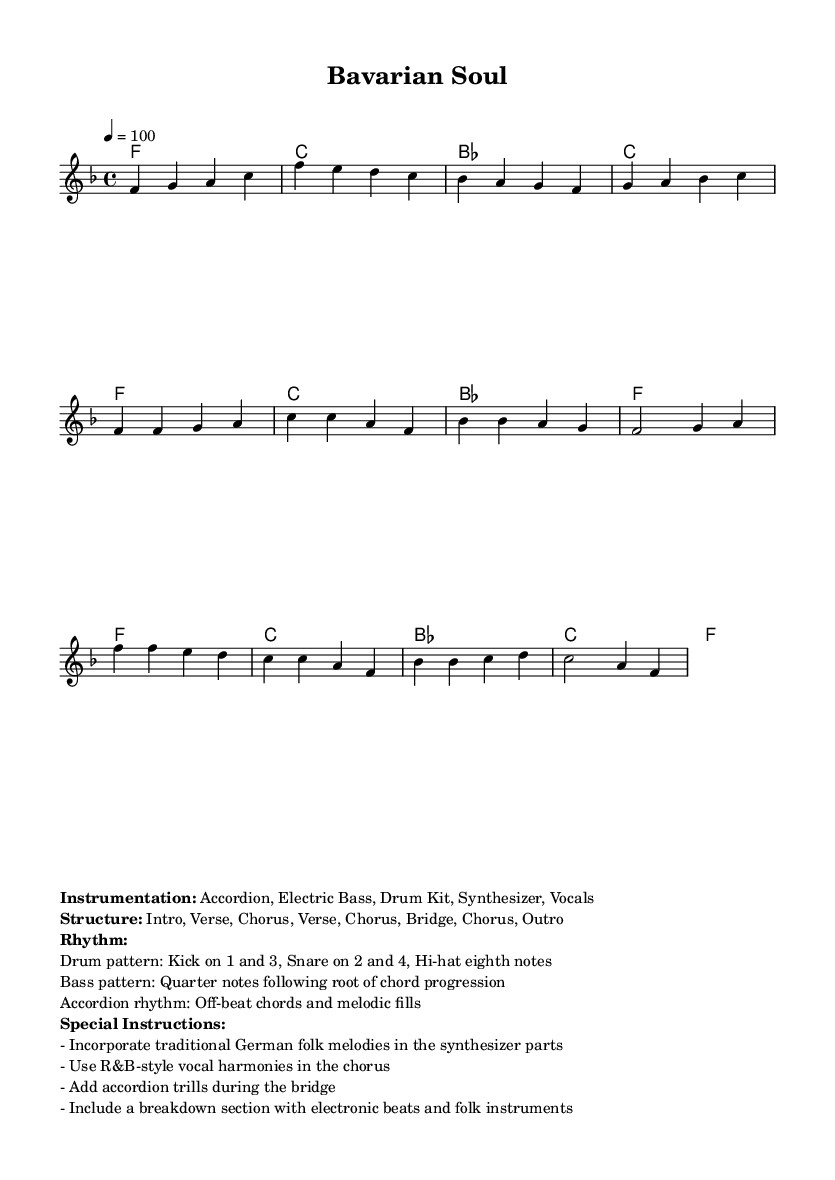What is the key signature of this music? The key signature is F major, which has one flat (B flat). This can be determined by looking at the key signature indicated at the beginning of the score.
Answer: F major What is the time signature of this piece? The time signature is 4/4, which is indicated at the beginning of the score. This means there are four beats per measure.
Answer: 4/4 What is the tempo marking? The tempo marking is quarter note = 100, which specifies the speed at which the piece should be played, indicated in beats per minute (BPM).
Answer: 100 How many sections are in the structure of the music? The structure consists of eight sections: Intro, Verse, Chorus, Verse, Chorus, Bridge, Chorus, and Outro, clearly noted in the markup section.
Answer: Eight What instruments are used in this piece? The instrumentation includes Accordion, Electric Bass, Drum Kit, Synthesizer, and Vocals, which are listed in the markup section for the piece.
Answer: Accordion, Electric Bass, Drum Kit, Synthesizer, Vocals What is the predominant drum pattern described? The drum pattern consists of a Kick on beats 1 and 3, and a Snare on beats 2 and 4, which is a common rhythmic pattern in R&B music, noted in the markup section.
Answer: Kick on 1 and 3, Snare on 2 and 4 What type of vocal harmonies are suggested for the chorus? The vocal harmonies suggested for the chorus are R&B-style, indicating a specific approach to vocal arrangement typical in Rhythm and Blues music as stated in the markup section.
Answer: R&B-style vocal harmonies 